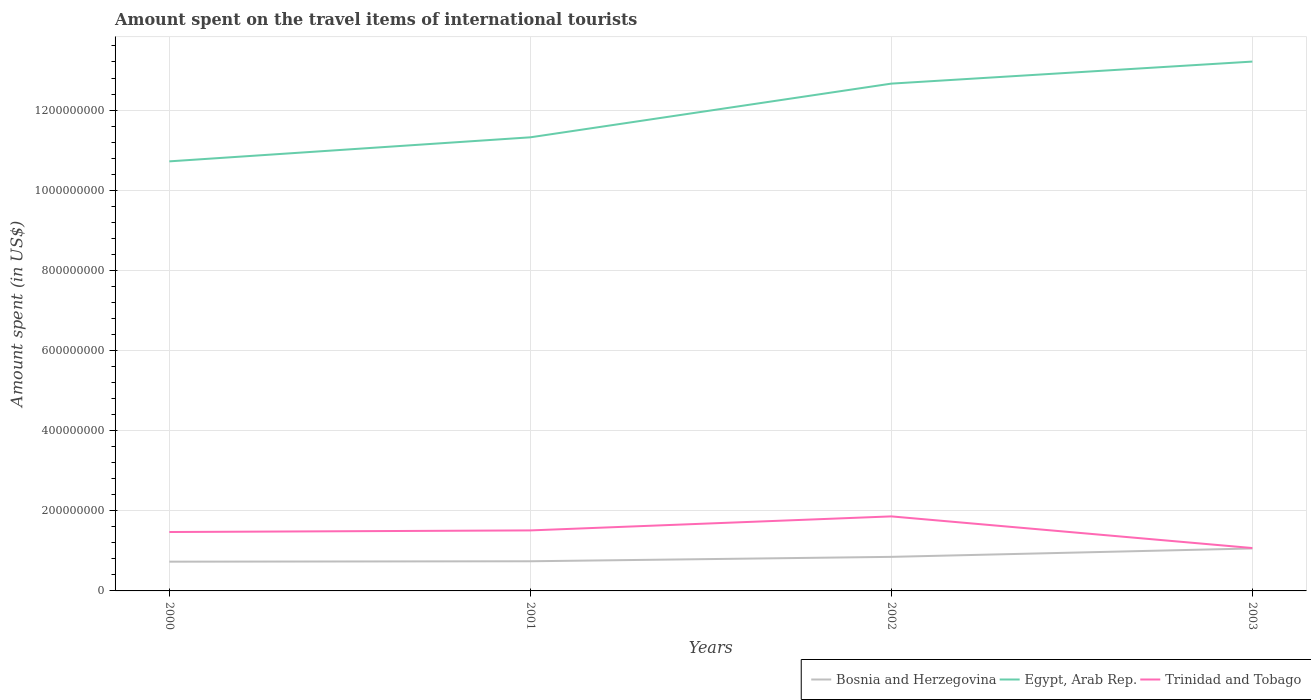Across all years, what is the maximum amount spent on the travel items of international tourists in Bosnia and Herzegovina?
Give a very brief answer. 7.30e+07. What is the total amount spent on the travel items of international tourists in Egypt, Arab Rep. in the graph?
Ensure brevity in your answer.  -1.89e+08. What is the difference between the highest and the second highest amount spent on the travel items of international tourists in Egypt, Arab Rep.?
Give a very brief answer. 2.49e+08. What is the difference between the highest and the lowest amount spent on the travel items of international tourists in Bosnia and Herzegovina?
Your response must be concise. 2. Is the amount spent on the travel items of international tourists in Trinidad and Tobago strictly greater than the amount spent on the travel items of international tourists in Egypt, Arab Rep. over the years?
Offer a very short reply. Yes. How many lines are there?
Keep it short and to the point. 3. How many years are there in the graph?
Ensure brevity in your answer.  4. Are the values on the major ticks of Y-axis written in scientific E-notation?
Your answer should be compact. No. Does the graph contain any zero values?
Your response must be concise. No. Where does the legend appear in the graph?
Make the answer very short. Bottom right. What is the title of the graph?
Provide a short and direct response. Amount spent on the travel items of international tourists. What is the label or title of the X-axis?
Make the answer very short. Years. What is the label or title of the Y-axis?
Give a very brief answer. Amount spent (in US$). What is the Amount spent (in US$) in Bosnia and Herzegovina in 2000?
Ensure brevity in your answer.  7.30e+07. What is the Amount spent (in US$) in Egypt, Arab Rep. in 2000?
Provide a short and direct response. 1.07e+09. What is the Amount spent (in US$) of Trinidad and Tobago in 2000?
Provide a short and direct response. 1.47e+08. What is the Amount spent (in US$) in Bosnia and Herzegovina in 2001?
Make the answer very short. 7.40e+07. What is the Amount spent (in US$) in Egypt, Arab Rep. in 2001?
Your answer should be very brief. 1.13e+09. What is the Amount spent (in US$) in Trinidad and Tobago in 2001?
Offer a terse response. 1.51e+08. What is the Amount spent (in US$) of Bosnia and Herzegovina in 2002?
Your answer should be very brief. 8.50e+07. What is the Amount spent (in US$) in Egypt, Arab Rep. in 2002?
Ensure brevity in your answer.  1.27e+09. What is the Amount spent (in US$) of Trinidad and Tobago in 2002?
Provide a short and direct response. 1.86e+08. What is the Amount spent (in US$) in Bosnia and Herzegovina in 2003?
Give a very brief answer. 1.06e+08. What is the Amount spent (in US$) in Egypt, Arab Rep. in 2003?
Offer a very short reply. 1.32e+09. What is the Amount spent (in US$) in Trinidad and Tobago in 2003?
Your answer should be very brief. 1.07e+08. Across all years, what is the maximum Amount spent (in US$) of Bosnia and Herzegovina?
Ensure brevity in your answer.  1.06e+08. Across all years, what is the maximum Amount spent (in US$) in Egypt, Arab Rep.?
Your response must be concise. 1.32e+09. Across all years, what is the maximum Amount spent (in US$) in Trinidad and Tobago?
Offer a terse response. 1.86e+08. Across all years, what is the minimum Amount spent (in US$) of Bosnia and Herzegovina?
Your answer should be compact. 7.30e+07. Across all years, what is the minimum Amount spent (in US$) in Egypt, Arab Rep.?
Your answer should be very brief. 1.07e+09. Across all years, what is the minimum Amount spent (in US$) of Trinidad and Tobago?
Your answer should be compact. 1.07e+08. What is the total Amount spent (in US$) of Bosnia and Herzegovina in the graph?
Offer a very short reply. 3.38e+08. What is the total Amount spent (in US$) of Egypt, Arab Rep. in the graph?
Ensure brevity in your answer.  4.79e+09. What is the total Amount spent (in US$) of Trinidad and Tobago in the graph?
Offer a very short reply. 5.91e+08. What is the difference between the Amount spent (in US$) of Egypt, Arab Rep. in 2000 and that in 2001?
Your answer should be compact. -6.00e+07. What is the difference between the Amount spent (in US$) of Trinidad and Tobago in 2000 and that in 2001?
Your answer should be compact. -4.00e+06. What is the difference between the Amount spent (in US$) of Bosnia and Herzegovina in 2000 and that in 2002?
Make the answer very short. -1.20e+07. What is the difference between the Amount spent (in US$) of Egypt, Arab Rep. in 2000 and that in 2002?
Make the answer very short. -1.94e+08. What is the difference between the Amount spent (in US$) in Trinidad and Tobago in 2000 and that in 2002?
Offer a very short reply. -3.90e+07. What is the difference between the Amount spent (in US$) of Bosnia and Herzegovina in 2000 and that in 2003?
Offer a very short reply. -3.30e+07. What is the difference between the Amount spent (in US$) of Egypt, Arab Rep. in 2000 and that in 2003?
Your answer should be compact. -2.49e+08. What is the difference between the Amount spent (in US$) of Trinidad and Tobago in 2000 and that in 2003?
Your answer should be very brief. 4.00e+07. What is the difference between the Amount spent (in US$) in Bosnia and Herzegovina in 2001 and that in 2002?
Your answer should be compact. -1.10e+07. What is the difference between the Amount spent (in US$) in Egypt, Arab Rep. in 2001 and that in 2002?
Make the answer very short. -1.34e+08. What is the difference between the Amount spent (in US$) of Trinidad and Tobago in 2001 and that in 2002?
Your answer should be compact. -3.50e+07. What is the difference between the Amount spent (in US$) in Bosnia and Herzegovina in 2001 and that in 2003?
Offer a terse response. -3.20e+07. What is the difference between the Amount spent (in US$) of Egypt, Arab Rep. in 2001 and that in 2003?
Your answer should be very brief. -1.89e+08. What is the difference between the Amount spent (in US$) of Trinidad and Tobago in 2001 and that in 2003?
Offer a very short reply. 4.40e+07. What is the difference between the Amount spent (in US$) in Bosnia and Herzegovina in 2002 and that in 2003?
Offer a very short reply. -2.10e+07. What is the difference between the Amount spent (in US$) in Egypt, Arab Rep. in 2002 and that in 2003?
Your answer should be compact. -5.50e+07. What is the difference between the Amount spent (in US$) in Trinidad and Tobago in 2002 and that in 2003?
Give a very brief answer. 7.90e+07. What is the difference between the Amount spent (in US$) in Bosnia and Herzegovina in 2000 and the Amount spent (in US$) in Egypt, Arab Rep. in 2001?
Your answer should be very brief. -1.06e+09. What is the difference between the Amount spent (in US$) in Bosnia and Herzegovina in 2000 and the Amount spent (in US$) in Trinidad and Tobago in 2001?
Your answer should be compact. -7.80e+07. What is the difference between the Amount spent (in US$) in Egypt, Arab Rep. in 2000 and the Amount spent (in US$) in Trinidad and Tobago in 2001?
Offer a terse response. 9.21e+08. What is the difference between the Amount spent (in US$) in Bosnia and Herzegovina in 2000 and the Amount spent (in US$) in Egypt, Arab Rep. in 2002?
Offer a very short reply. -1.19e+09. What is the difference between the Amount spent (in US$) in Bosnia and Herzegovina in 2000 and the Amount spent (in US$) in Trinidad and Tobago in 2002?
Offer a very short reply. -1.13e+08. What is the difference between the Amount spent (in US$) in Egypt, Arab Rep. in 2000 and the Amount spent (in US$) in Trinidad and Tobago in 2002?
Ensure brevity in your answer.  8.86e+08. What is the difference between the Amount spent (in US$) in Bosnia and Herzegovina in 2000 and the Amount spent (in US$) in Egypt, Arab Rep. in 2003?
Provide a short and direct response. -1.25e+09. What is the difference between the Amount spent (in US$) in Bosnia and Herzegovina in 2000 and the Amount spent (in US$) in Trinidad and Tobago in 2003?
Keep it short and to the point. -3.40e+07. What is the difference between the Amount spent (in US$) of Egypt, Arab Rep. in 2000 and the Amount spent (in US$) of Trinidad and Tobago in 2003?
Make the answer very short. 9.65e+08. What is the difference between the Amount spent (in US$) of Bosnia and Herzegovina in 2001 and the Amount spent (in US$) of Egypt, Arab Rep. in 2002?
Offer a terse response. -1.19e+09. What is the difference between the Amount spent (in US$) in Bosnia and Herzegovina in 2001 and the Amount spent (in US$) in Trinidad and Tobago in 2002?
Give a very brief answer. -1.12e+08. What is the difference between the Amount spent (in US$) of Egypt, Arab Rep. in 2001 and the Amount spent (in US$) of Trinidad and Tobago in 2002?
Give a very brief answer. 9.46e+08. What is the difference between the Amount spent (in US$) in Bosnia and Herzegovina in 2001 and the Amount spent (in US$) in Egypt, Arab Rep. in 2003?
Make the answer very short. -1.25e+09. What is the difference between the Amount spent (in US$) in Bosnia and Herzegovina in 2001 and the Amount spent (in US$) in Trinidad and Tobago in 2003?
Your response must be concise. -3.30e+07. What is the difference between the Amount spent (in US$) in Egypt, Arab Rep. in 2001 and the Amount spent (in US$) in Trinidad and Tobago in 2003?
Your answer should be very brief. 1.02e+09. What is the difference between the Amount spent (in US$) of Bosnia and Herzegovina in 2002 and the Amount spent (in US$) of Egypt, Arab Rep. in 2003?
Make the answer very short. -1.24e+09. What is the difference between the Amount spent (in US$) in Bosnia and Herzegovina in 2002 and the Amount spent (in US$) in Trinidad and Tobago in 2003?
Ensure brevity in your answer.  -2.20e+07. What is the difference between the Amount spent (in US$) in Egypt, Arab Rep. in 2002 and the Amount spent (in US$) in Trinidad and Tobago in 2003?
Your answer should be very brief. 1.16e+09. What is the average Amount spent (in US$) of Bosnia and Herzegovina per year?
Make the answer very short. 8.45e+07. What is the average Amount spent (in US$) of Egypt, Arab Rep. per year?
Provide a succinct answer. 1.20e+09. What is the average Amount spent (in US$) of Trinidad and Tobago per year?
Make the answer very short. 1.48e+08. In the year 2000, what is the difference between the Amount spent (in US$) of Bosnia and Herzegovina and Amount spent (in US$) of Egypt, Arab Rep.?
Make the answer very short. -9.99e+08. In the year 2000, what is the difference between the Amount spent (in US$) of Bosnia and Herzegovina and Amount spent (in US$) of Trinidad and Tobago?
Ensure brevity in your answer.  -7.40e+07. In the year 2000, what is the difference between the Amount spent (in US$) in Egypt, Arab Rep. and Amount spent (in US$) in Trinidad and Tobago?
Give a very brief answer. 9.25e+08. In the year 2001, what is the difference between the Amount spent (in US$) in Bosnia and Herzegovina and Amount spent (in US$) in Egypt, Arab Rep.?
Your response must be concise. -1.06e+09. In the year 2001, what is the difference between the Amount spent (in US$) in Bosnia and Herzegovina and Amount spent (in US$) in Trinidad and Tobago?
Your response must be concise. -7.70e+07. In the year 2001, what is the difference between the Amount spent (in US$) in Egypt, Arab Rep. and Amount spent (in US$) in Trinidad and Tobago?
Make the answer very short. 9.81e+08. In the year 2002, what is the difference between the Amount spent (in US$) of Bosnia and Herzegovina and Amount spent (in US$) of Egypt, Arab Rep.?
Make the answer very short. -1.18e+09. In the year 2002, what is the difference between the Amount spent (in US$) in Bosnia and Herzegovina and Amount spent (in US$) in Trinidad and Tobago?
Make the answer very short. -1.01e+08. In the year 2002, what is the difference between the Amount spent (in US$) of Egypt, Arab Rep. and Amount spent (in US$) of Trinidad and Tobago?
Your answer should be compact. 1.08e+09. In the year 2003, what is the difference between the Amount spent (in US$) of Bosnia and Herzegovina and Amount spent (in US$) of Egypt, Arab Rep.?
Ensure brevity in your answer.  -1.22e+09. In the year 2003, what is the difference between the Amount spent (in US$) of Bosnia and Herzegovina and Amount spent (in US$) of Trinidad and Tobago?
Your answer should be very brief. -1.00e+06. In the year 2003, what is the difference between the Amount spent (in US$) of Egypt, Arab Rep. and Amount spent (in US$) of Trinidad and Tobago?
Provide a short and direct response. 1.21e+09. What is the ratio of the Amount spent (in US$) in Bosnia and Herzegovina in 2000 to that in 2001?
Offer a terse response. 0.99. What is the ratio of the Amount spent (in US$) of Egypt, Arab Rep. in 2000 to that in 2001?
Your response must be concise. 0.95. What is the ratio of the Amount spent (in US$) of Trinidad and Tobago in 2000 to that in 2001?
Provide a short and direct response. 0.97. What is the ratio of the Amount spent (in US$) in Bosnia and Herzegovina in 2000 to that in 2002?
Make the answer very short. 0.86. What is the ratio of the Amount spent (in US$) of Egypt, Arab Rep. in 2000 to that in 2002?
Give a very brief answer. 0.85. What is the ratio of the Amount spent (in US$) in Trinidad and Tobago in 2000 to that in 2002?
Your answer should be very brief. 0.79. What is the ratio of the Amount spent (in US$) of Bosnia and Herzegovina in 2000 to that in 2003?
Your answer should be compact. 0.69. What is the ratio of the Amount spent (in US$) of Egypt, Arab Rep. in 2000 to that in 2003?
Provide a succinct answer. 0.81. What is the ratio of the Amount spent (in US$) of Trinidad and Tobago in 2000 to that in 2003?
Your answer should be very brief. 1.37. What is the ratio of the Amount spent (in US$) in Bosnia and Herzegovina in 2001 to that in 2002?
Provide a short and direct response. 0.87. What is the ratio of the Amount spent (in US$) of Egypt, Arab Rep. in 2001 to that in 2002?
Ensure brevity in your answer.  0.89. What is the ratio of the Amount spent (in US$) of Trinidad and Tobago in 2001 to that in 2002?
Offer a terse response. 0.81. What is the ratio of the Amount spent (in US$) in Bosnia and Herzegovina in 2001 to that in 2003?
Provide a succinct answer. 0.7. What is the ratio of the Amount spent (in US$) in Egypt, Arab Rep. in 2001 to that in 2003?
Provide a short and direct response. 0.86. What is the ratio of the Amount spent (in US$) of Trinidad and Tobago in 2001 to that in 2003?
Offer a terse response. 1.41. What is the ratio of the Amount spent (in US$) in Bosnia and Herzegovina in 2002 to that in 2003?
Your response must be concise. 0.8. What is the ratio of the Amount spent (in US$) in Egypt, Arab Rep. in 2002 to that in 2003?
Offer a terse response. 0.96. What is the ratio of the Amount spent (in US$) of Trinidad and Tobago in 2002 to that in 2003?
Make the answer very short. 1.74. What is the difference between the highest and the second highest Amount spent (in US$) in Bosnia and Herzegovina?
Offer a very short reply. 2.10e+07. What is the difference between the highest and the second highest Amount spent (in US$) in Egypt, Arab Rep.?
Keep it short and to the point. 5.50e+07. What is the difference between the highest and the second highest Amount spent (in US$) of Trinidad and Tobago?
Provide a succinct answer. 3.50e+07. What is the difference between the highest and the lowest Amount spent (in US$) of Bosnia and Herzegovina?
Give a very brief answer. 3.30e+07. What is the difference between the highest and the lowest Amount spent (in US$) of Egypt, Arab Rep.?
Provide a short and direct response. 2.49e+08. What is the difference between the highest and the lowest Amount spent (in US$) of Trinidad and Tobago?
Offer a terse response. 7.90e+07. 